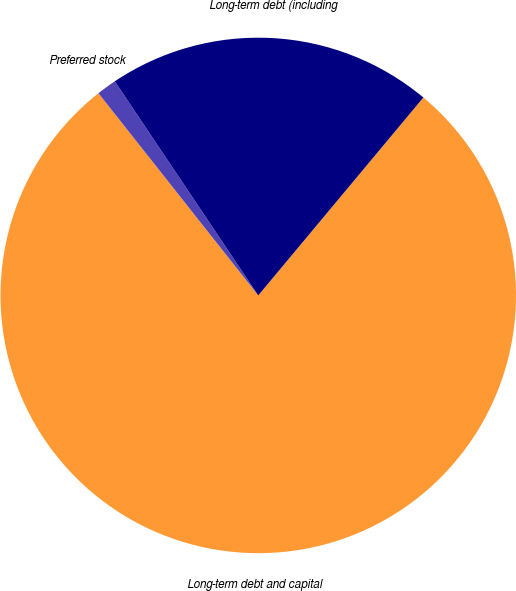Convert chart to OTSL. <chart><loc_0><loc_0><loc_500><loc_500><pie_chart><fcel>Long-term debt and capital<fcel>Preferred stock<fcel>Long-term debt (including<nl><fcel>78.29%<fcel>1.25%<fcel>20.46%<nl></chart> 